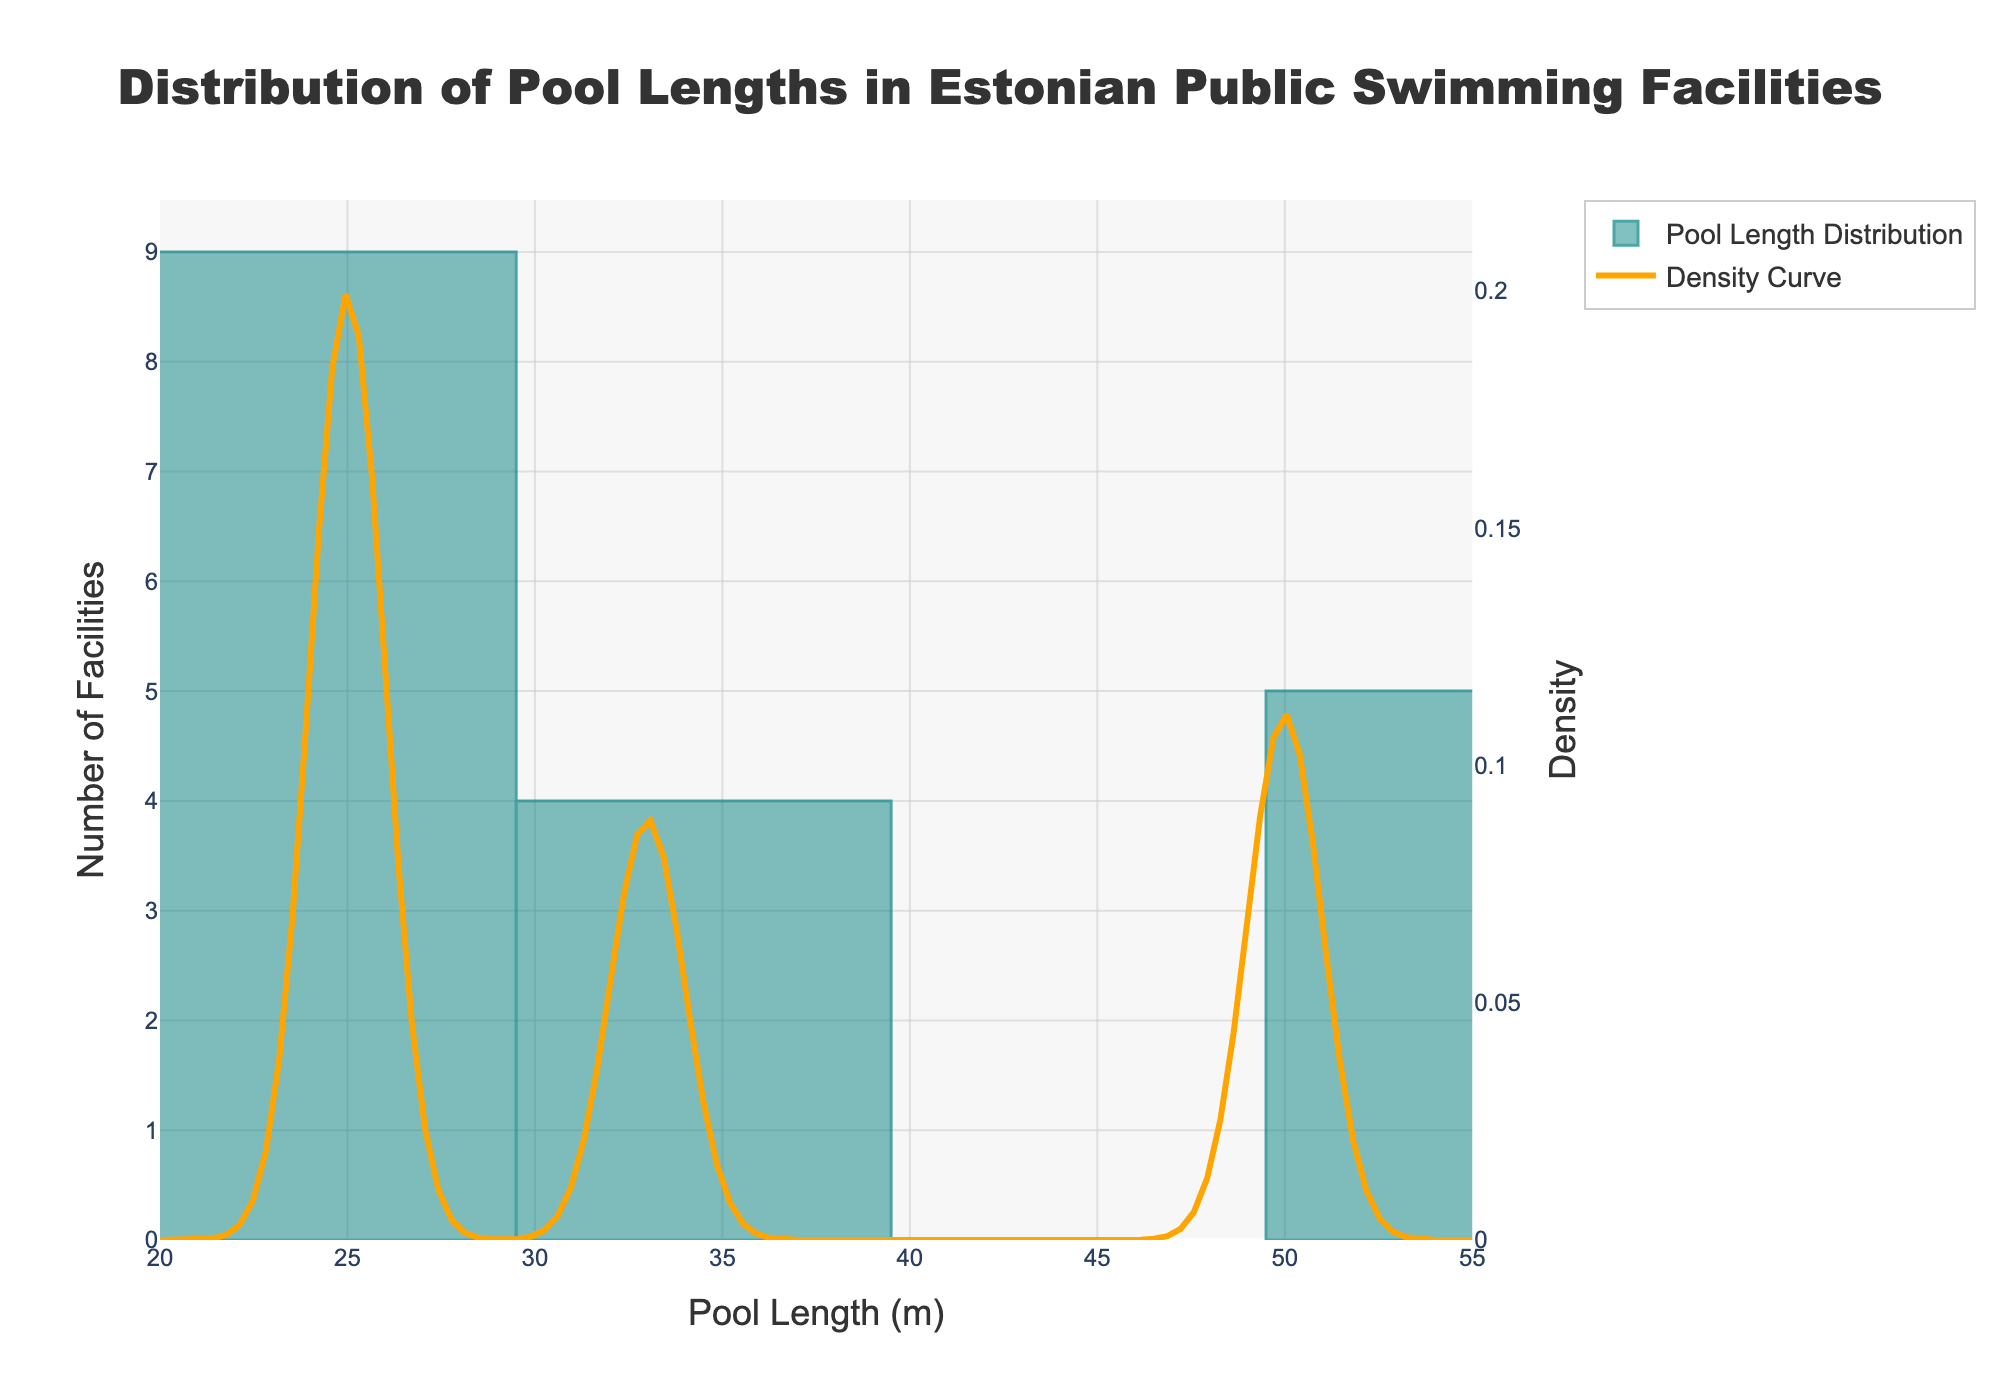What is the title of the figure? The title is located at the top of the figure and is intended to give a brief description of what the figure represents.
Answer: Distribution of Pool Lengths in Estonian Public Swimming Facilities How many different pool lengths are represented in the histogram? By looking at the x-axis and noting the unique positions of the bins in the histogram, we can count the distinct pool lengths.
Answer: Three (25m, 33m, 50m) Which pool length has the highest number of facilities? Refer to the histogram bar that reaches the highest point on the y-axis, which represents the number of facilities.
Answer: 25 meters How many facilities have a pool length of 50 meters? Find the bar on the histogram corresponding to 50 meters on the x-axis and read the y-axis value for the number of facilities.
Answer: 5 facilities Is the density curve highest for 25-meter pools or 50-meter pools? Observe the KDE (density curve) and compare the heights at the positions corresponding to 25 meters and 50 meters on the x-axis.
Answer: 25 meters What is the range of the x-axis? Refer to the x-axis labels to determine the range covered by the histogram.
Answer: 20 to 55 meters What is the bin width for the histogram? Count the number of bins and determine the span each covers on the 20 to 55 meters range.
Answer: 7 meters Which pool length contributes most to the density at 25 meters? Notice that density is highest around 25 meters. Refer to the KDE curve to deduce the contributing factor.
Answer: 25 meters Are any of the pool lengths equally spread in the histogram? Look at the heights of the bars for each pool length. To be evenly spread, the bars would have to be of similar height.
Answer: No Compare the density of 33-meter pools to 50-meter pools. Which one is higher and why? Assess the height of the KDE curve at the positions corresponding to 33 meters and 50 meters on the x-axis, and compare the values. The 33 meters' density is higher because the KDE curve value is greater at 33 meters.
Answer: 33 meters 